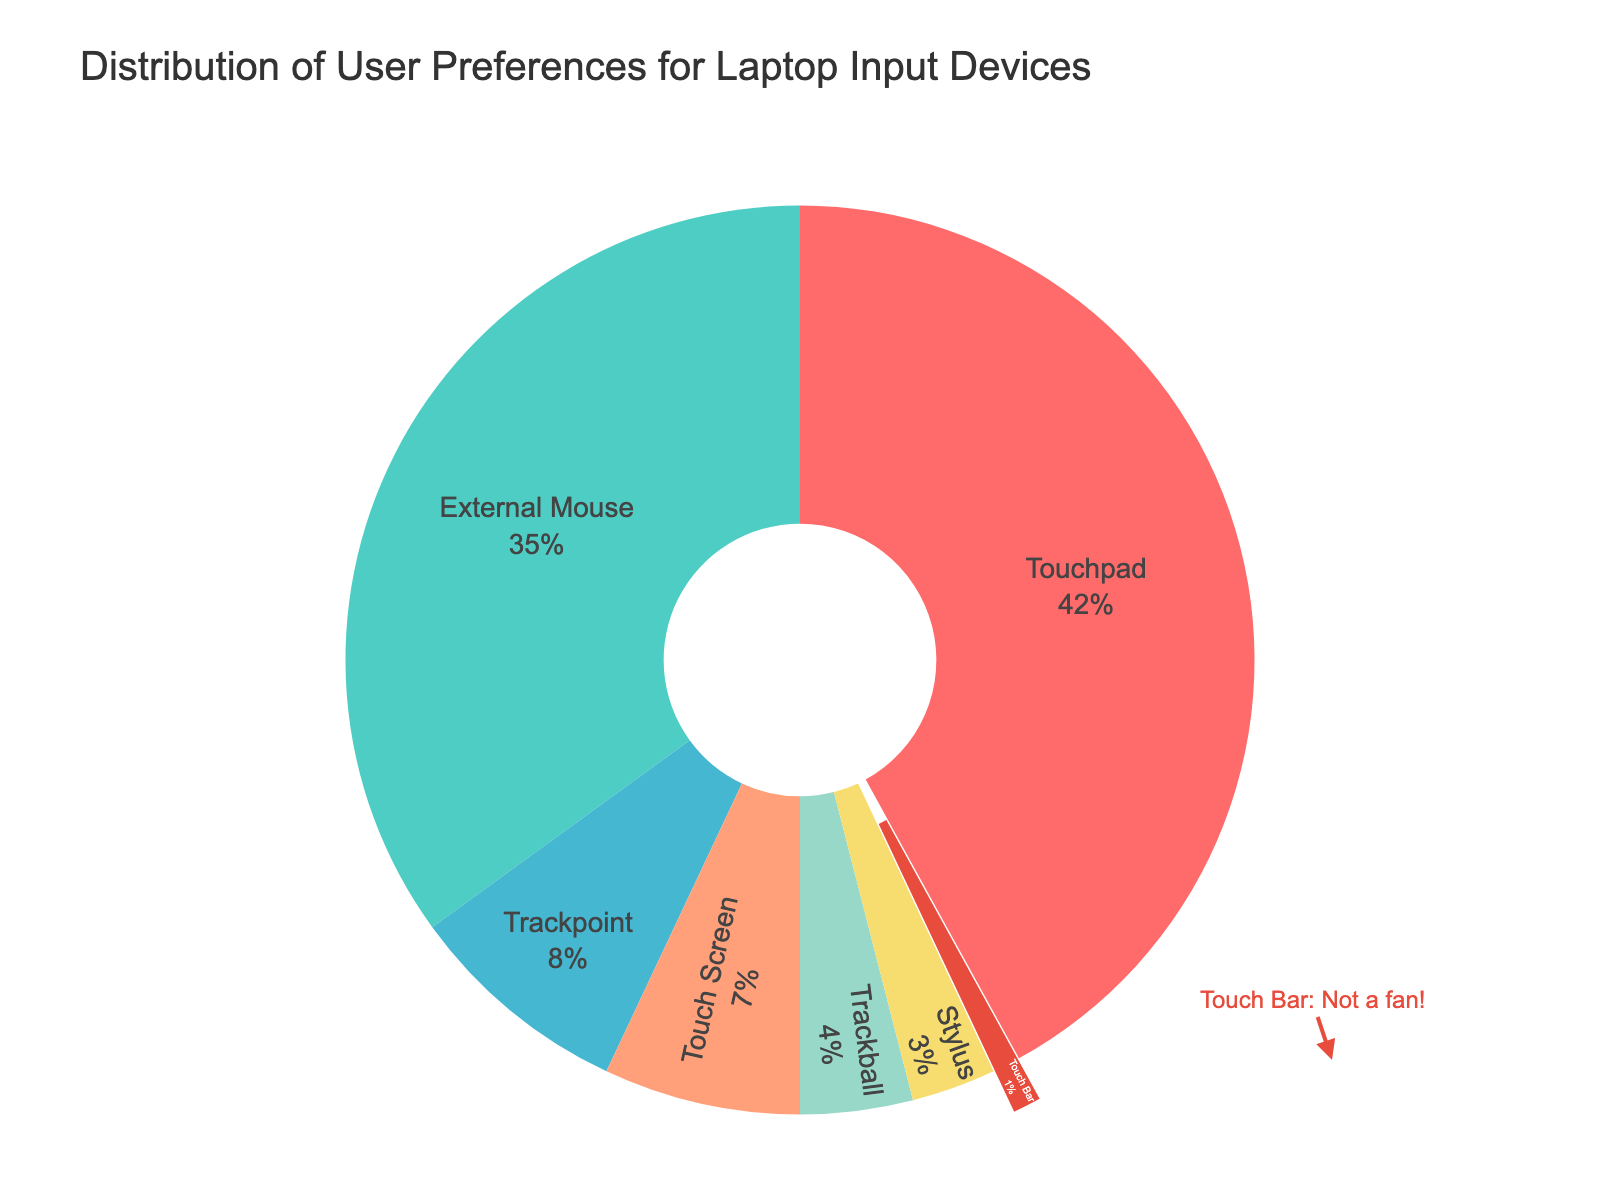What's the most preferred laptop input device according to the chart? The segment with the largest proportion represents the most preferred input device. The Touchpad segment is the largest.
Answer: Touchpad What's the total percentage of users that prefer external devices (e.g., External Mouse, Stylus, Trackball)? Sum the percentages for External Mouse, Trackball, and Stylus. They are 35%, 4%, and 3%, respectively. 35 + 4 + 3 = 42
Answer: 42% How does the preference for a trackpoint compare to the preference for a Touch Screen? Compare the percentage values of Trackpoint (8%) and Touch Screen (7%). 8 is greater than 7.
Answer: Trackpoint is more preferred What percentage of users prefer the Touch Bar? Look directly at the chart's information for the Touch Bar. The segment for the Touch Bar represents 1%.
Answer: 1% Which input device is the least preferred, and how is it visually marked in the chart? The smallest segment in the pie chart represents the least preferred input device, and for this chart, it is the Touch Bar. Additionally, the Touch Bar section is visually emphasized by being pulled out slightly.
Answer: Touch Bar; pulled out How much more do users prefer the Touchpad over the Trackpoint? Find the difference between the preferences for Touchpad (42%) and Trackpoint (8%). 42 - 8 = 34
Answer: 34% If you combine the preferences for all the input devices except External Mouse and Touchpad, what would the total percentage be? Add up the percentages of Trackpoint (8%), Touch Screen (7%), Trackball (4%), Stylus (3%), and Touch Bar (1%). 8 + 7 + 4 + 3 + 1 = 23
Answer: 23% What's the difference in user preference percentages between the Touchpad and the External Mouse? Subtract the percentage for External Mouse (35%) from the percentage for Touchpad (42%). 42 - 35 = 7
Answer: 7% List all the input devices represented in the chart. Name all input devices shown in the pie chart: Touchpad, External Mouse, Trackpoint, Touch Screen, Trackball, Stylus, and Touch Bar.
Answer: Touchpad, External Mouse, Trackpoint, Touch Screen, Trackball, Stylus, Touch Bar 